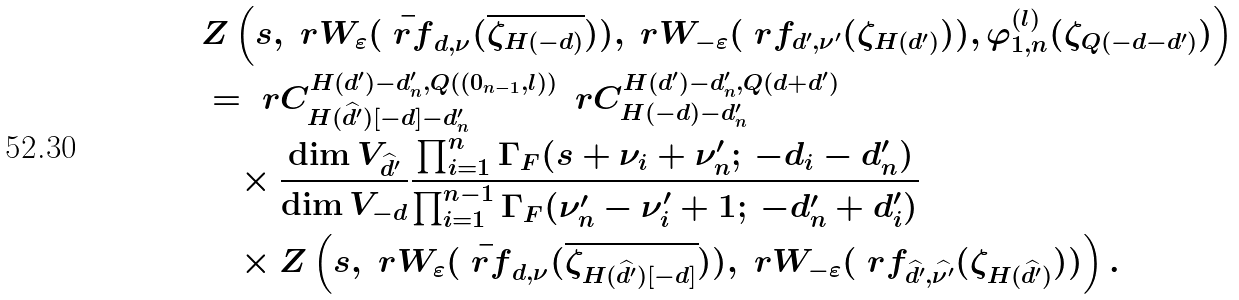Convert formula to latex. <formula><loc_0><loc_0><loc_500><loc_500>& Z \left ( s , \ r W _ { \varepsilon } ( \bar { \ r f } _ { d , \nu } ( \overline { \zeta _ { H ( - d ) } } ) ) , \ r W _ { - \varepsilon } ( \ r f _ { d ^ { \prime } , \nu ^ { \prime } } ( \zeta _ { H ( d ^ { \prime } ) } ) ) , \varphi _ { 1 , n } ^ { ( l ) } ( \zeta _ { Q ( - d - d ^ { \prime } ) } ) \right ) \\ & = \ r C ^ { H ( d ^ { \prime } ) - d _ { n } ^ { \prime } , Q ( ( 0 _ { n - 1 } , l ) ) } _ { H ( \widehat { d ^ { \prime } } ) [ - d ] - d _ { n } ^ { \prime } } \, { \ r C ^ { H ( d ^ { \prime } ) - d _ { n } ^ { \prime } , Q ( d + d ^ { \prime } ) } _ { H ( - d ) - d _ { n } ^ { \prime } } } \\ & \quad \times \frac { \dim V _ { \widehat { d ^ { \prime } } } } { \dim V _ { - d } } \frac { \prod _ { i = 1 } ^ { n } \Gamma _ { F } ( s + \nu _ { i } + \nu _ { n } ^ { \prime } ; \, - d _ { i } - d _ { n } ^ { \prime } ) } { \prod _ { i = 1 } ^ { n - 1 } \Gamma _ { F } ( \nu _ { n } ^ { \prime } - \nu _ { i } ^ { \prime } + 1 ; \, - d _ { n } ^ { \prime } + d _ { i } ^ { \prime } ) } \\ & \quad \times Z \left ( s , \ r W _ { \varepsilon } ( \bar { \ r f } _ { d , \nu } ( \overline { \zeta _ { H ( \widehat { d ^ { \prime } } ) [ - d ] } } ) ) , \ r W _ { - \varepsilon } ( \ r f _ { \widehat { d ^ { \prime } } , \widehat { \nu ^ { \prime } } } ( \zeta _ { H ( \widehat { d ^ { \prime } } ) } ) ) \right ) .</formula> 